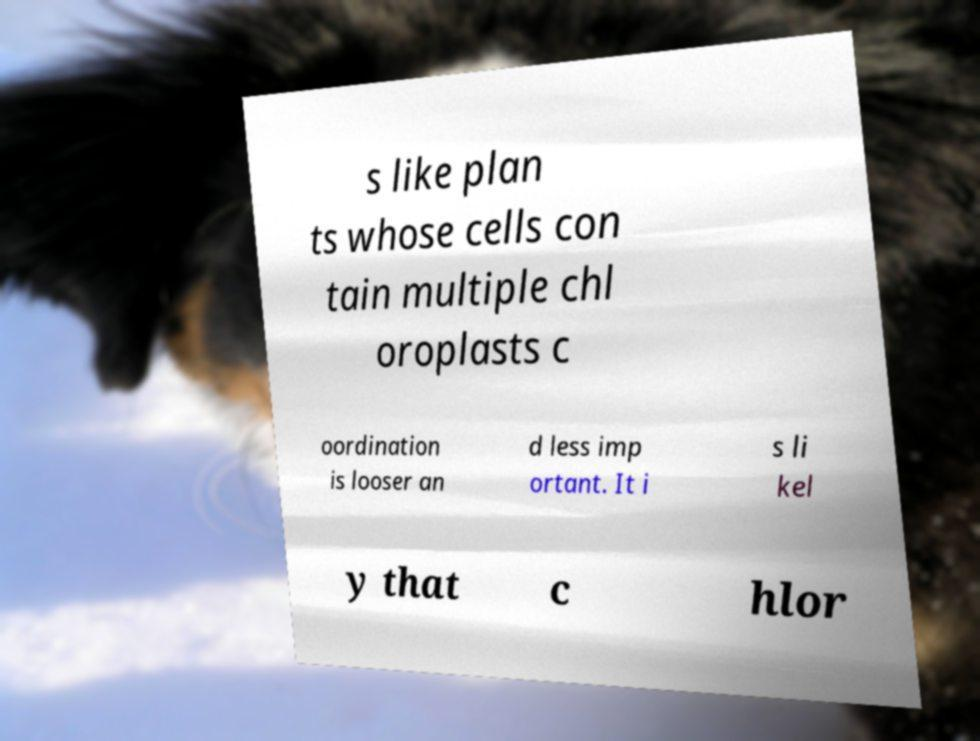Please read and relay the text visible in this image. What does it say? s like plan ts whose cells con tain multiple chl oroplasts c oordination is looser an d less imp ortant. It i s li kel y that c hlor 